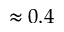Convert formula to latex. <formula><loc_0><loc_0><loc_500><loc_500>\approx 0 . 4</formula> 